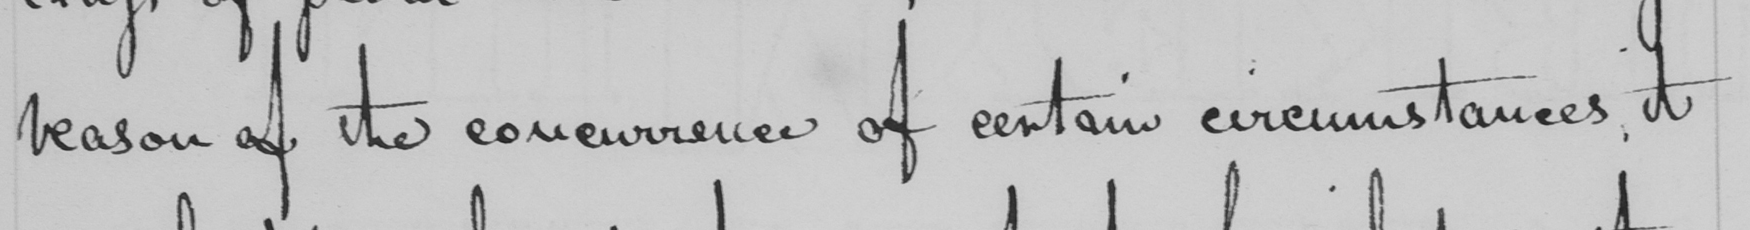What text is written in this handwritten line? reason of the concurrence of certain circumstances, it 